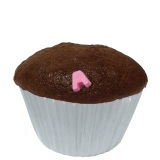What would be a short description of this dessert for a bakery menu? A moist chocolate cupcake topped with a charming pink fondant heart. Perfect for any sweet occasion.  Now, describe it in a more elaborate and enticing way for the bakery menu. Indulge in our decadent chocolate cupcake, a rich and moist delight baked to perfection. Each cupcake is crowned with a single pink fondant heart, adding a whimsical touch to this classic treat. The perfect balance of sweetness and elegance, it's sure to bring a smile to your face with every delicious bite. 